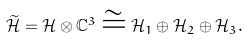Convert formula to latex. <formula><loc_0><loc_0><loc_500><loc_500>\widetilde { \mathcal { H } } = { \mathcal { H } } \otimes { \mathbb { C } } ^ { 3 } \cong { \mathcal { H } } _ { 1 } \oplus { \mathcal { H } } _ { 2 } \oplus { \mathcal { H } } _ { 3 } .</formula> 